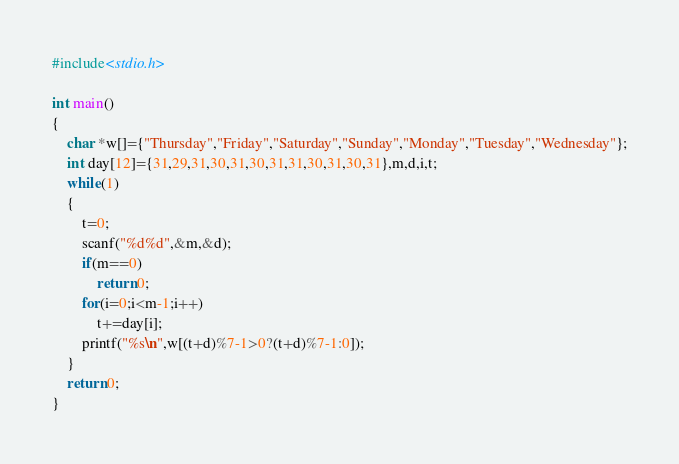Convert code to text. <code><loc_0><loc_0><loc_500><loc_500><_C_>#include<stdio.h>

int main()
{
	char *w[]={"Thursday","Friday","Saturday","Sunday","Monday","Tuesday","Wednesday"};
	int day[12]={31,29,31,30,31,30,31,31,30,31,30,31},m,d,i,t;
	while(1)
	{
		t=0;
		scanf("%d%d",&m,&d);
		if(m==0)
			return 0;
		for(i=0;i<m-1;i++)
			t+=day[i];
		printf("%s\n",w[(t+d)%7-1>0?(t+d)%7-1:0]);
	}
	return 0;
}</code> 